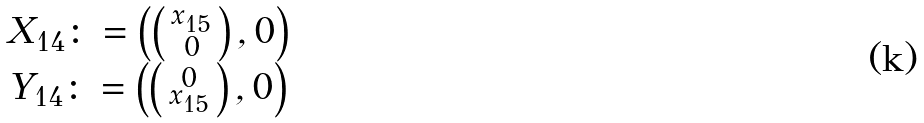Convert formula to latex. <formula><loc_0><loc_0><loc_500><loc_500>\begin{matrix} X _ { 1 4 } \colon = \left ( \left ( \begin{smallmatrix} x _ { 1 5 } \\ 0 \end{smallmatrix} \right ) , 0 \right ) \\ Y _ { 1 4 } \colon = \left ( \left ( \begin{smallmatrix} 0 \\ x _ { 1 5 } \end{smallmatrix} \right ) , 0 \right ) \end{matrix}</formula> 